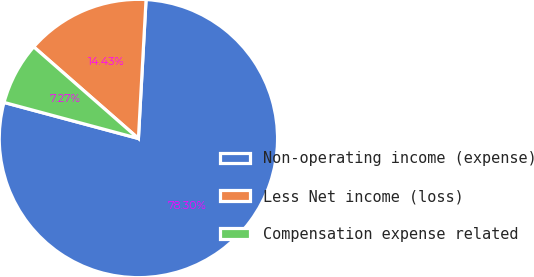<chart> <loc_0><loc_0><loc_500><loc_500><pie_chart><fcel>Non-operating income (expense)<fcel>Less Net income (loss)<fcel>Compensation expense related<nl><fcel>78.3%<fcel>14.43%<fcel>7.27%<nl></chart> 